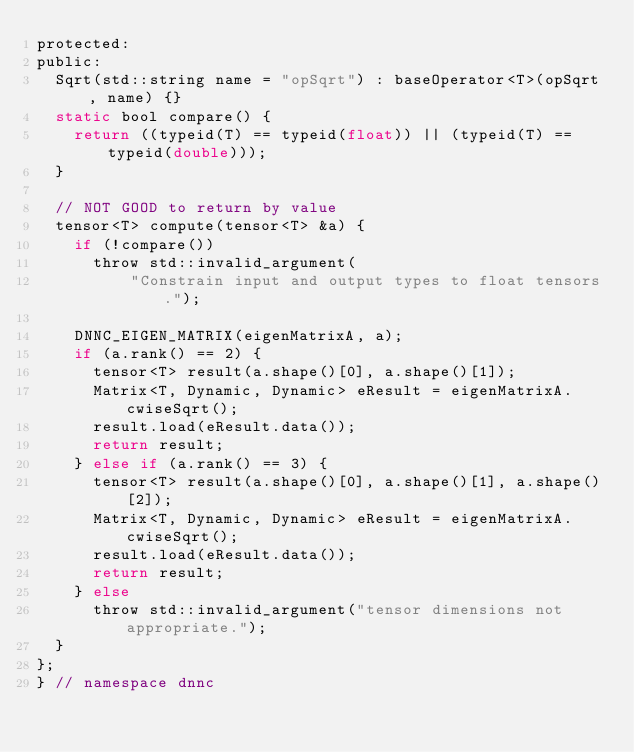Convert code to text. <code><loc_0><loc_0><loc_500><loc_500><_C_>protected:
public:
  Sqrt(std::string name = "opSqrt") : baseOperator<T>(opSqrt, name) {}
  static bool compare() {
    return ((typeid(T) == typeid(float)) || (typeid(T) == typeid(double)));
  }

  // NOT GOOD to return by value
  tensor<T> compute(tensor<T> &a) {
    if (!compare())
      throw std::invalid_argument(
          "Constrain input and output types to float tensors.");

    DNNC_EIGEN_MATRIX(eigenMatrixA, a);
    if (a.rank() == 2) {
      tensor<T> result(a.shape()[0], a.shape()[1]);
      Matrix<T, Dynamic, Dynamic> eResult = eigenMatrixA.cwiseSqrt();
      result.load(eResult.data());
      return result;
    } else if (a.rank() == 3) {
      tensor<T> result(a.shape()[0], a.shape()[1], a.shape()[2]);
      Matrix<T, Dynamic, Dynamic> eResult = eigenMatrixA.cwiseSqrt();
      result.load(eResult.data());
      return result;
    } else
      throw std::invalid_argument("tensor dimensions not appropriate.");
  }
};
} // namespace dnnc
</code> 